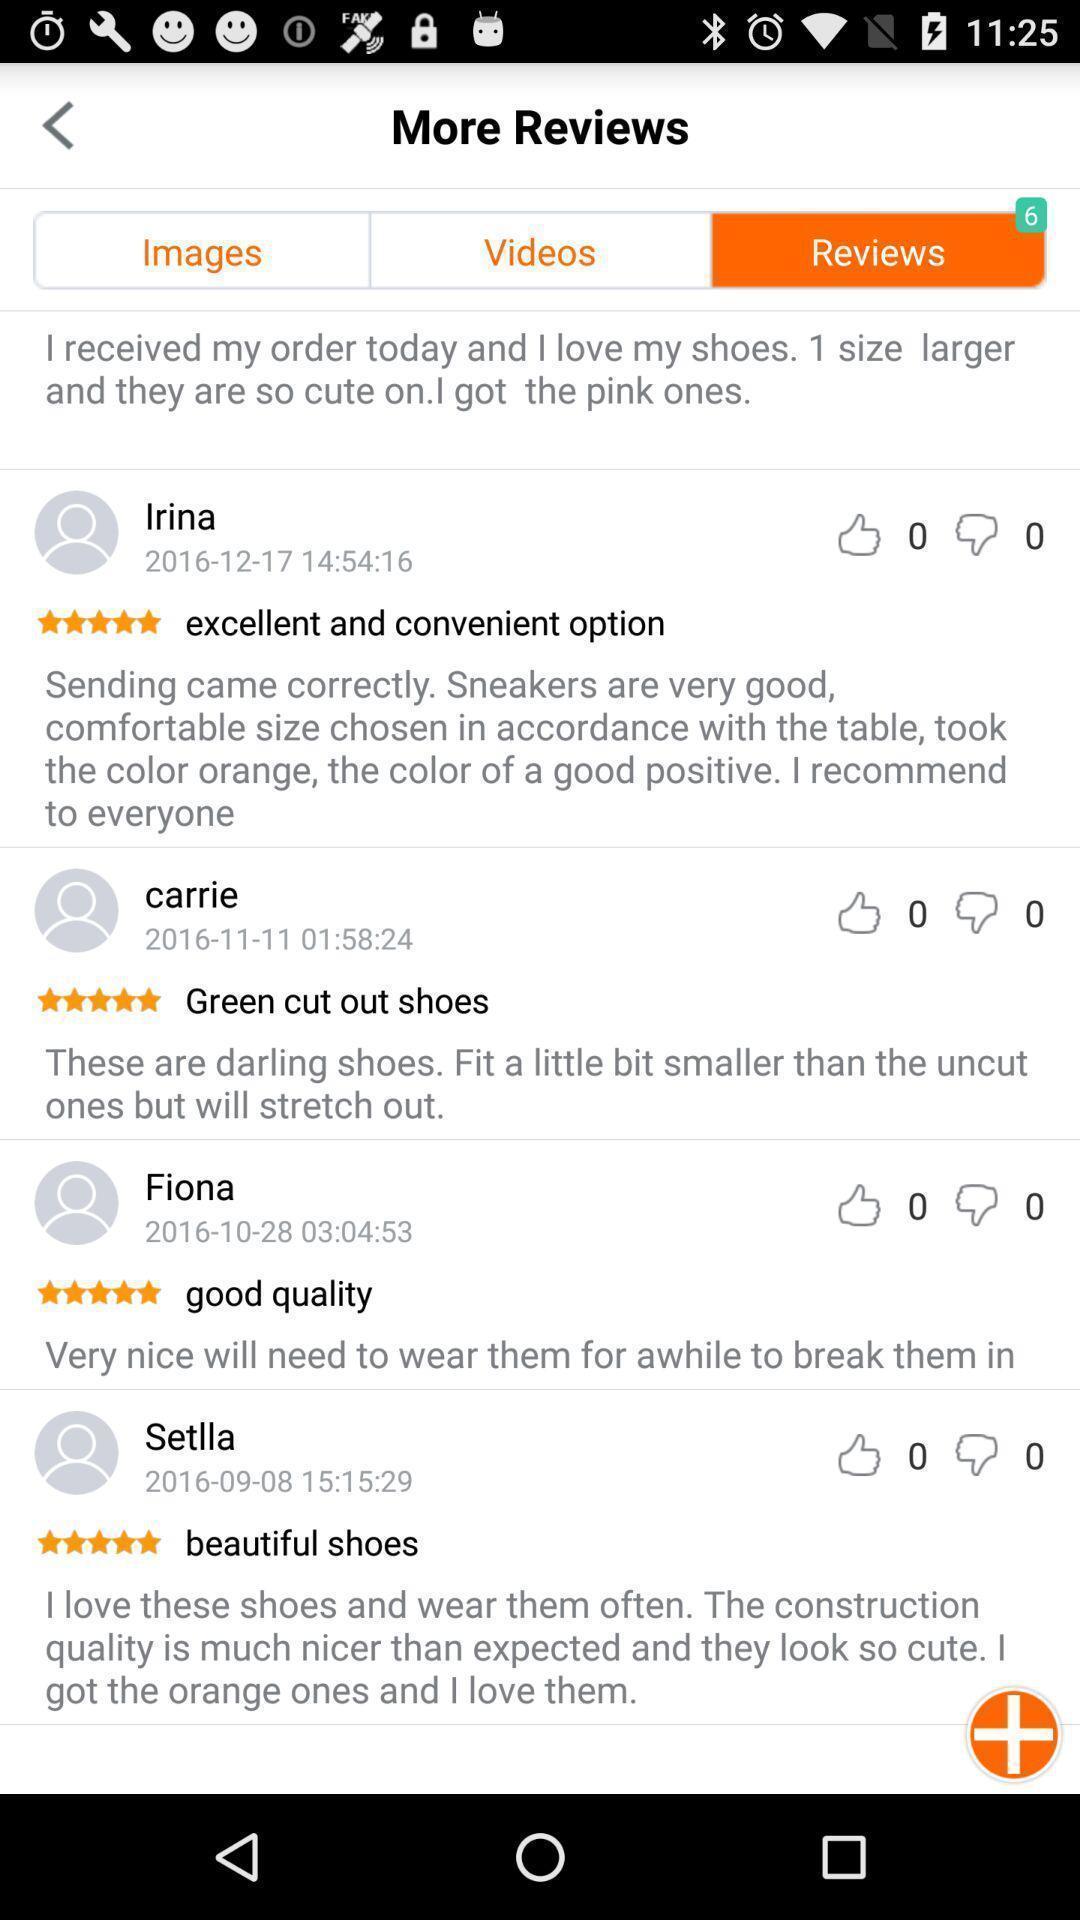Tell me what you see in this picture. Review page of a shopping application. 